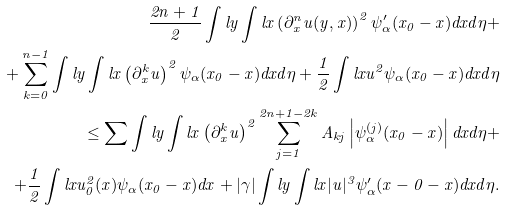<formula> <loc_0><loc_0><loc_500><loc_500>\frac { 2 n + 1 } { 2 } \int l y \int l x \left ( \partial _ { x } ^ { n } u ( y , x ) \right ) ^ { 2 } \psi _ { \alpha } ^ { \prime } ( x _ { 0 } - x ) d x d \eta + \\ + \sum _ { k = 0 } ^ { n - 1 } \int l y \int l x \left ( \partial _ { x } ^ { k } u \right ) ^ { 2 } \psi _ { \alpha } ( x _ { 0 } - x ) d x d \eta + \frac { 1 } { 2 } \int l x u ^ { 2 } \psi _ { \alpha } ( x _ { 0 } - x ) d x d \eta \\ \leq \sum \int l y \int l x \left ( \partial _ { x } ^ { k } u \right ) ^ { 2 } \sum _ { j = 1 } ^ { 2 n + 1 - 2 k } A _ { k j } \left | \psi _ { \alpha } ^ { ( j ) } ( x _ { 0 } - x ) \right | d x d \eta + \\ + \frac { 1 } { 2 } \int l x u _ { 0 } ^ { 2 } ( x ) \psi _ { \alpha } ( x _ { 0 } - x ) d x + | \gamma | \int l y \int l x | u | ^ { 3 } \psi _ { \alpha } ^ { \prime } ( x - 0 - x ) d x d \eta .</formula> 